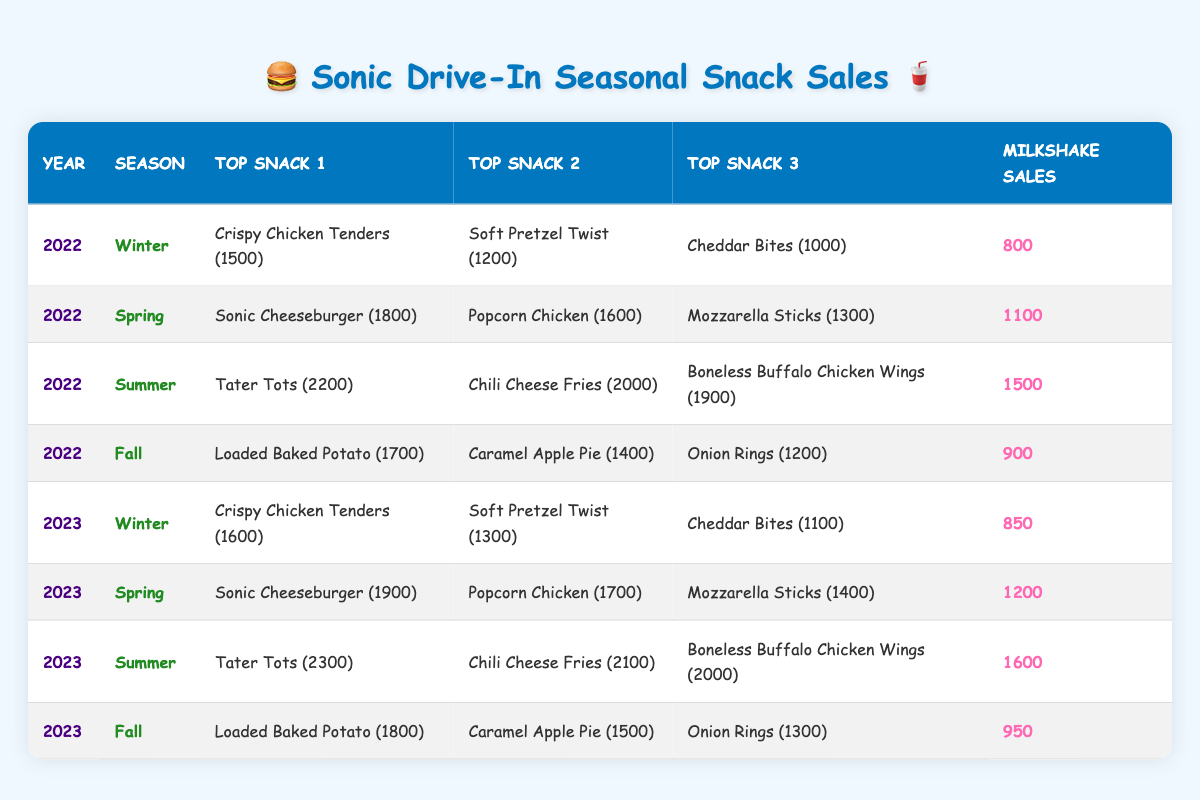What were the top snacks sold in Winter 2022? From the table, the top snacks for Winter 2022 are Crispy Chicken Tenders with 1500 sales, Soft Pretzel Twist with 1200 sales, and Cheddar Bites with 1000 sales.
Answer: Crispy Chicken Tenders, Soft Pretzel Twist, Cheddar Bites Which season had the highest milkshake sales in 2022? Looking at the milkshake sales for each season in 2022: Winter had 800, Spring had 1100, Summer had 1500, and Fall had 900. The highest is Summer with 1500 milkshake sales.
Answer: Summer Did milkshake sales increase from Winter 2022 to Winter 2023? Winter 2022 had 800 milkshake sales, while Winter 2023 had 850. Since 850 is greater than 800, it confirms that there was an increase.
Answer: Yes What was the difference in sales of Tater Tots between Summer 2022 and Summer 2023? In Summer 2022 Tater Tots sold 2200, while in Summer 2023 they sold 2300. The difference is calculated as 2300 - 2200, which equals 100.
Answer: 100 Which snack had the highest sales in Spring 2023? In Spring 2023, the top snack was Sonic Cheeseburger with 1900 sales. The other snacks, Popcorn Chicken and Mozzarella Sticks, had 1700 and 1400 sales, respectively.
Answer: Sonic Cheeseburger What is the average milkshake sales for the Fall seasons from 2022 to 2023? Fall 2022 had 900 milkshake sales and Fall 2023 had 950. To find the average, we add these values: 900 + 950 = 1850, and then divide by 2, which gives us 1850/2 = 925.
Answer: 925 Were Crispy Chicken Tenders sold more in Winter 2023 than in Winter 2022? In Winter 2022, Crispy Chicken Tenders had 1500 sales, while in Winter 2023, they had 1600 sales. Since 1600 is greater than 1500, the statement is true.
Answer: Yes What was the total sales of Loaded Baked Potato across both Fall seasons? The sales figures for Loaded Baked Potato are 1700 in Fall 2022 and 1800 in Fall 2023. Adding these gives us 1700 + 1800 = 3500 total sales across both seasons.
Answer: 3500 